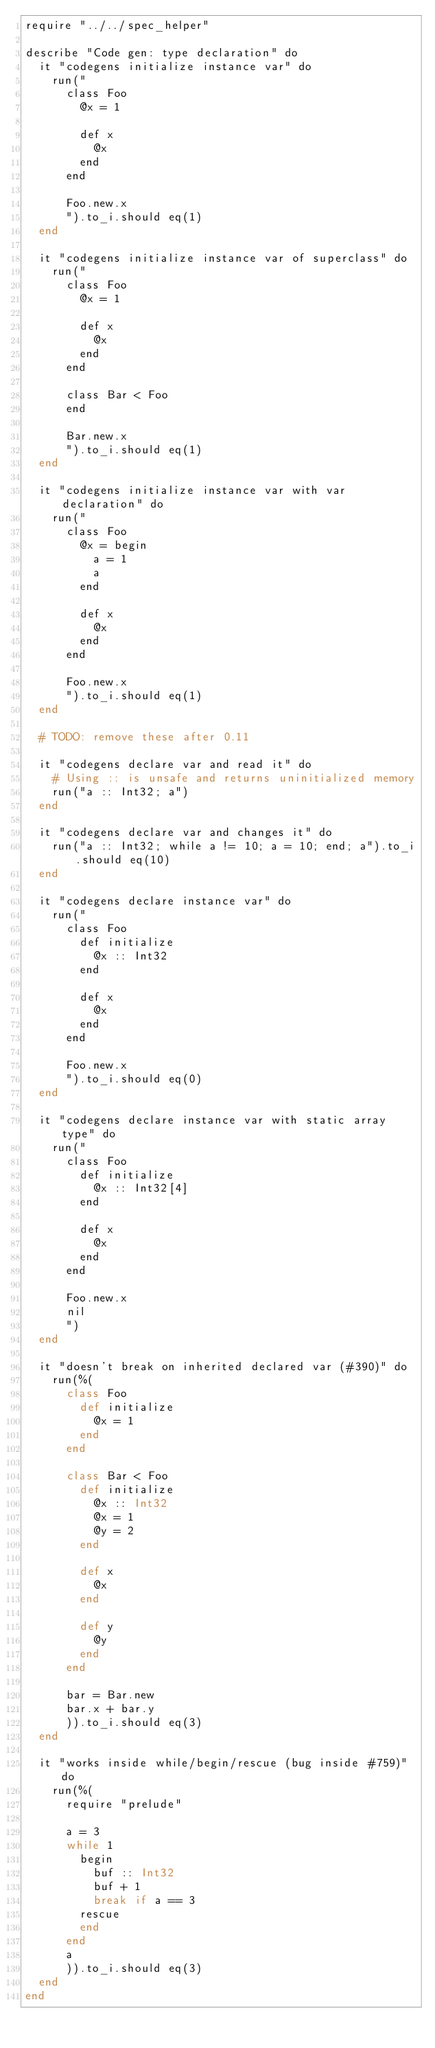Convert code to text. <code><loc_0><loc_0><loc_500><loc_500><_Crystal_>require "../../spec_helper"

describe "Code gen: type declaration" do
  it "codegens initialize instance var" do
    run("
      class Foo
        @x = 1

        def x
          @x
        end
      end

      Foo.new.x
      ").to_i.should eq(1)
  end

  it "codegens initialize instance var of superclass" do
    run("
      class Foo
        @x = 1

        def x
          @x
        end
      end

      class Bar < Foo
      end

      Bar.new.x
      ").to_i.should eq(1)
  end

  it "codegens initialize instance var with var declaration" do
    run("
      class Foo
        @x = begin
          a = 1
          a
        end

        def x
          @x
        end
      end

      Foo.new.x
      ").to_i.should eq(1)
  end

  # TODO: remove these after 0.11

  it "codegens declare var and read it" do
    # Using :: is unsafe and returns uninitialized memory
    run("a :: Int32; a")
  end

  it "codegens declare var and changes it" do
    run("a :: Int32; while a != 10; a = 10; end; a").to_i.should eq(10)
  end

  it "codegens declare instance var" do
    run("
      class Foo
        def initialize
          @x :: Int32
        end

        def x
          @x
        end
      end

      Foo.new.x
      ").to_i.should eq(0)
  end

  it "codegens declare instance var with static array type" do
    run("
      class Foo
        def initialize
          @x :: Int32[4]
        end

        def x
          @x
        end
      end

      Foo.new.x
      nil
      ")
  end

  it "doesn't break on inherited declared var (#390)" do
    run(%(
      class Foo
        def initialize
          @x = 1
        end
      end

      class Bar < Foo
        def initialize
          @x :: Int32
          @x = 1
          @y = 2
        end

        def x
          @x
        end

        def y
          @y
        end
      end

      bar = Bar.new
      bar.x + bar.y
      )).to_i.should eq(3)
  end

  it "works inside while/begin/rescue (bug inside #759)" do
    run(%(
      require "prelude"

      a = 3
      while 1
        begin
          buf :: Int32
          buf + 1
          break if a == 3
        rescue
        end
      end
      a
      )).to_i.should eq(3)
  end
end
</code> 